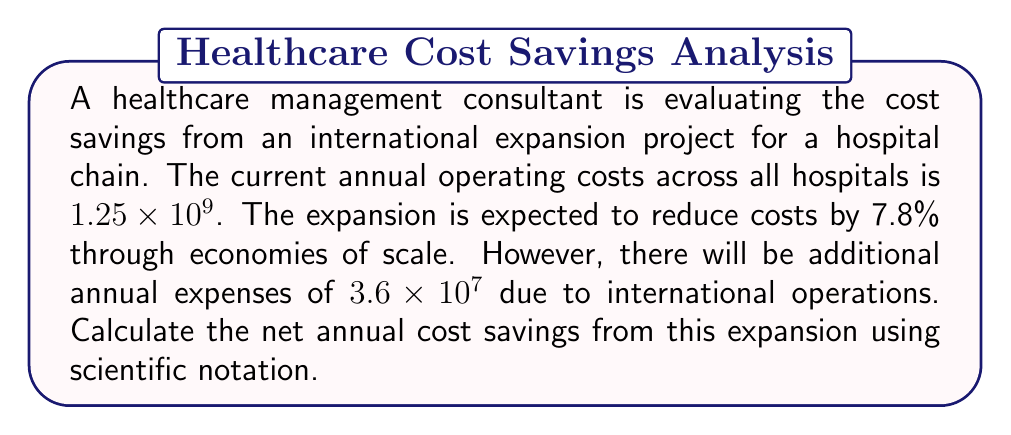Could you help me with this problem? Let's approach this step-by-step:

1) First, calculate the cost reduction from the 7.8% savings:
   $$1.25 \times 10^9 \times 0.078 = 9.75 \times 10^7$$

2) Now, subtract the additional expenses:
   $$9.75 \times 10^7 - 3.6 \times 10^7 = 6.15 \times 10^7$$

3) To ensure the answer is in proper scientific notation, we need to adjust the coefficient to be between 1 and 10:
   $$6.15 \times 10^7 = 6.15 \times 10^7$$

The result is already in proper scientific notation, so no further adjustment is needed.
Answer: $6.15 \times 10^7$ 